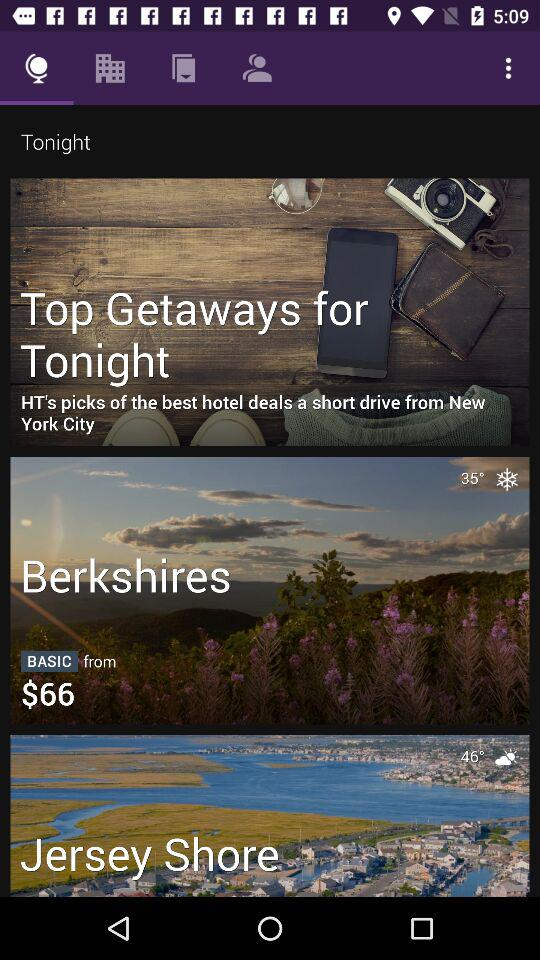What is the temperature at the Jersey Shore? The temperature at the Jersey Shore is 46°. 